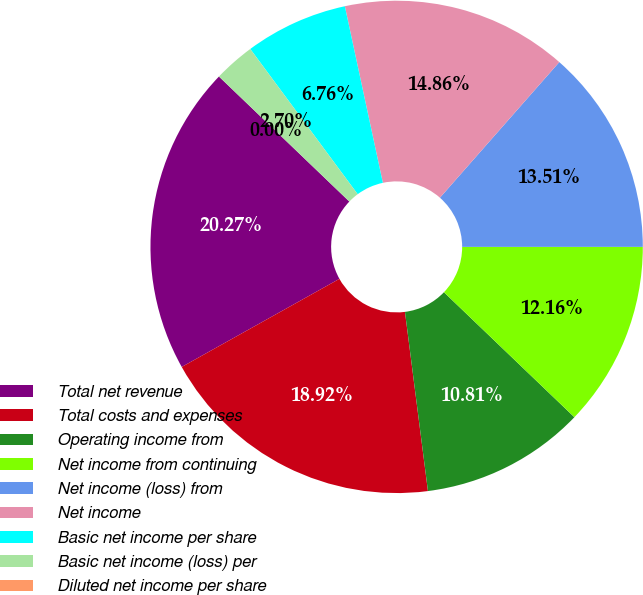Convert chart. <chart><loc_0><loc_0><loc_500><loc_500><pie_chart><fcel>Total net revenue<fcel>Total costs and expenses<fcel>Operating income from<fcel>Net income from continuing<fcel>Net income (loss) from<fcel>Net income<fcel>Basic net income per share<fcel>Basic net income (loss) per<fcel>Diluted net income per share<nl><fcel>20.27%<fcel>18.92%<fcel>10.81%<fcel>12.16%<fcel>13.51%<fcel>14.86%<fcel>6.76%<fcel>2.7%<fcel>0.0%<nl></chart> 